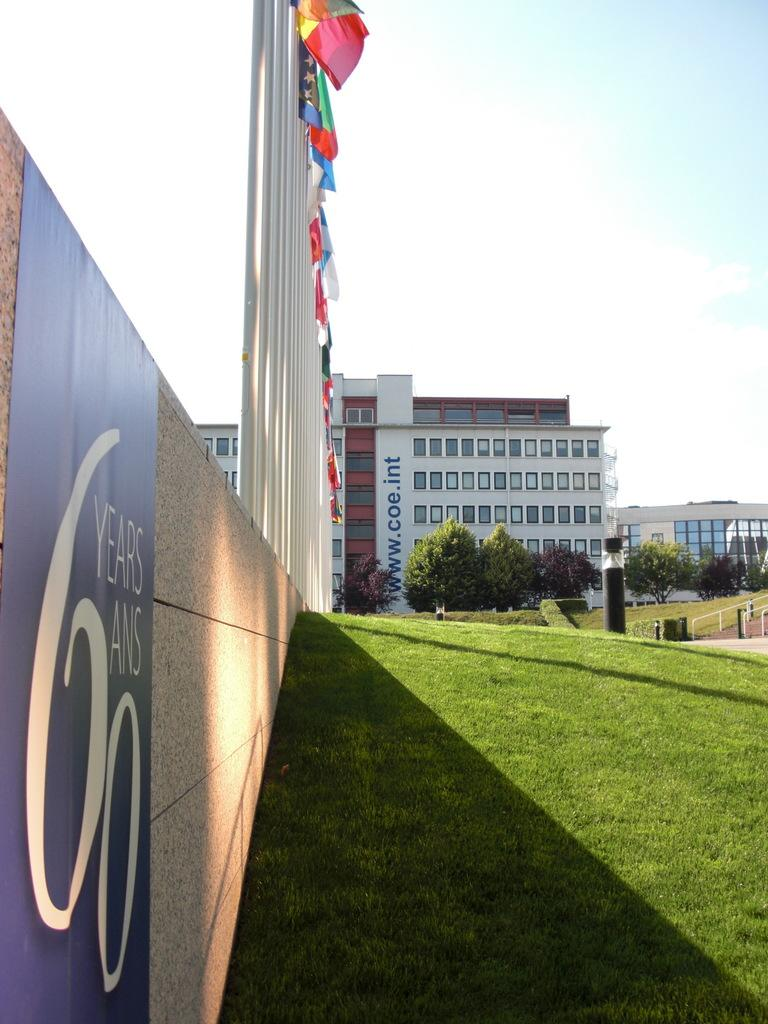<image>
Offer a succinct explanation of the picture presented. A banner on the grass in front a building that reads 60 years. 